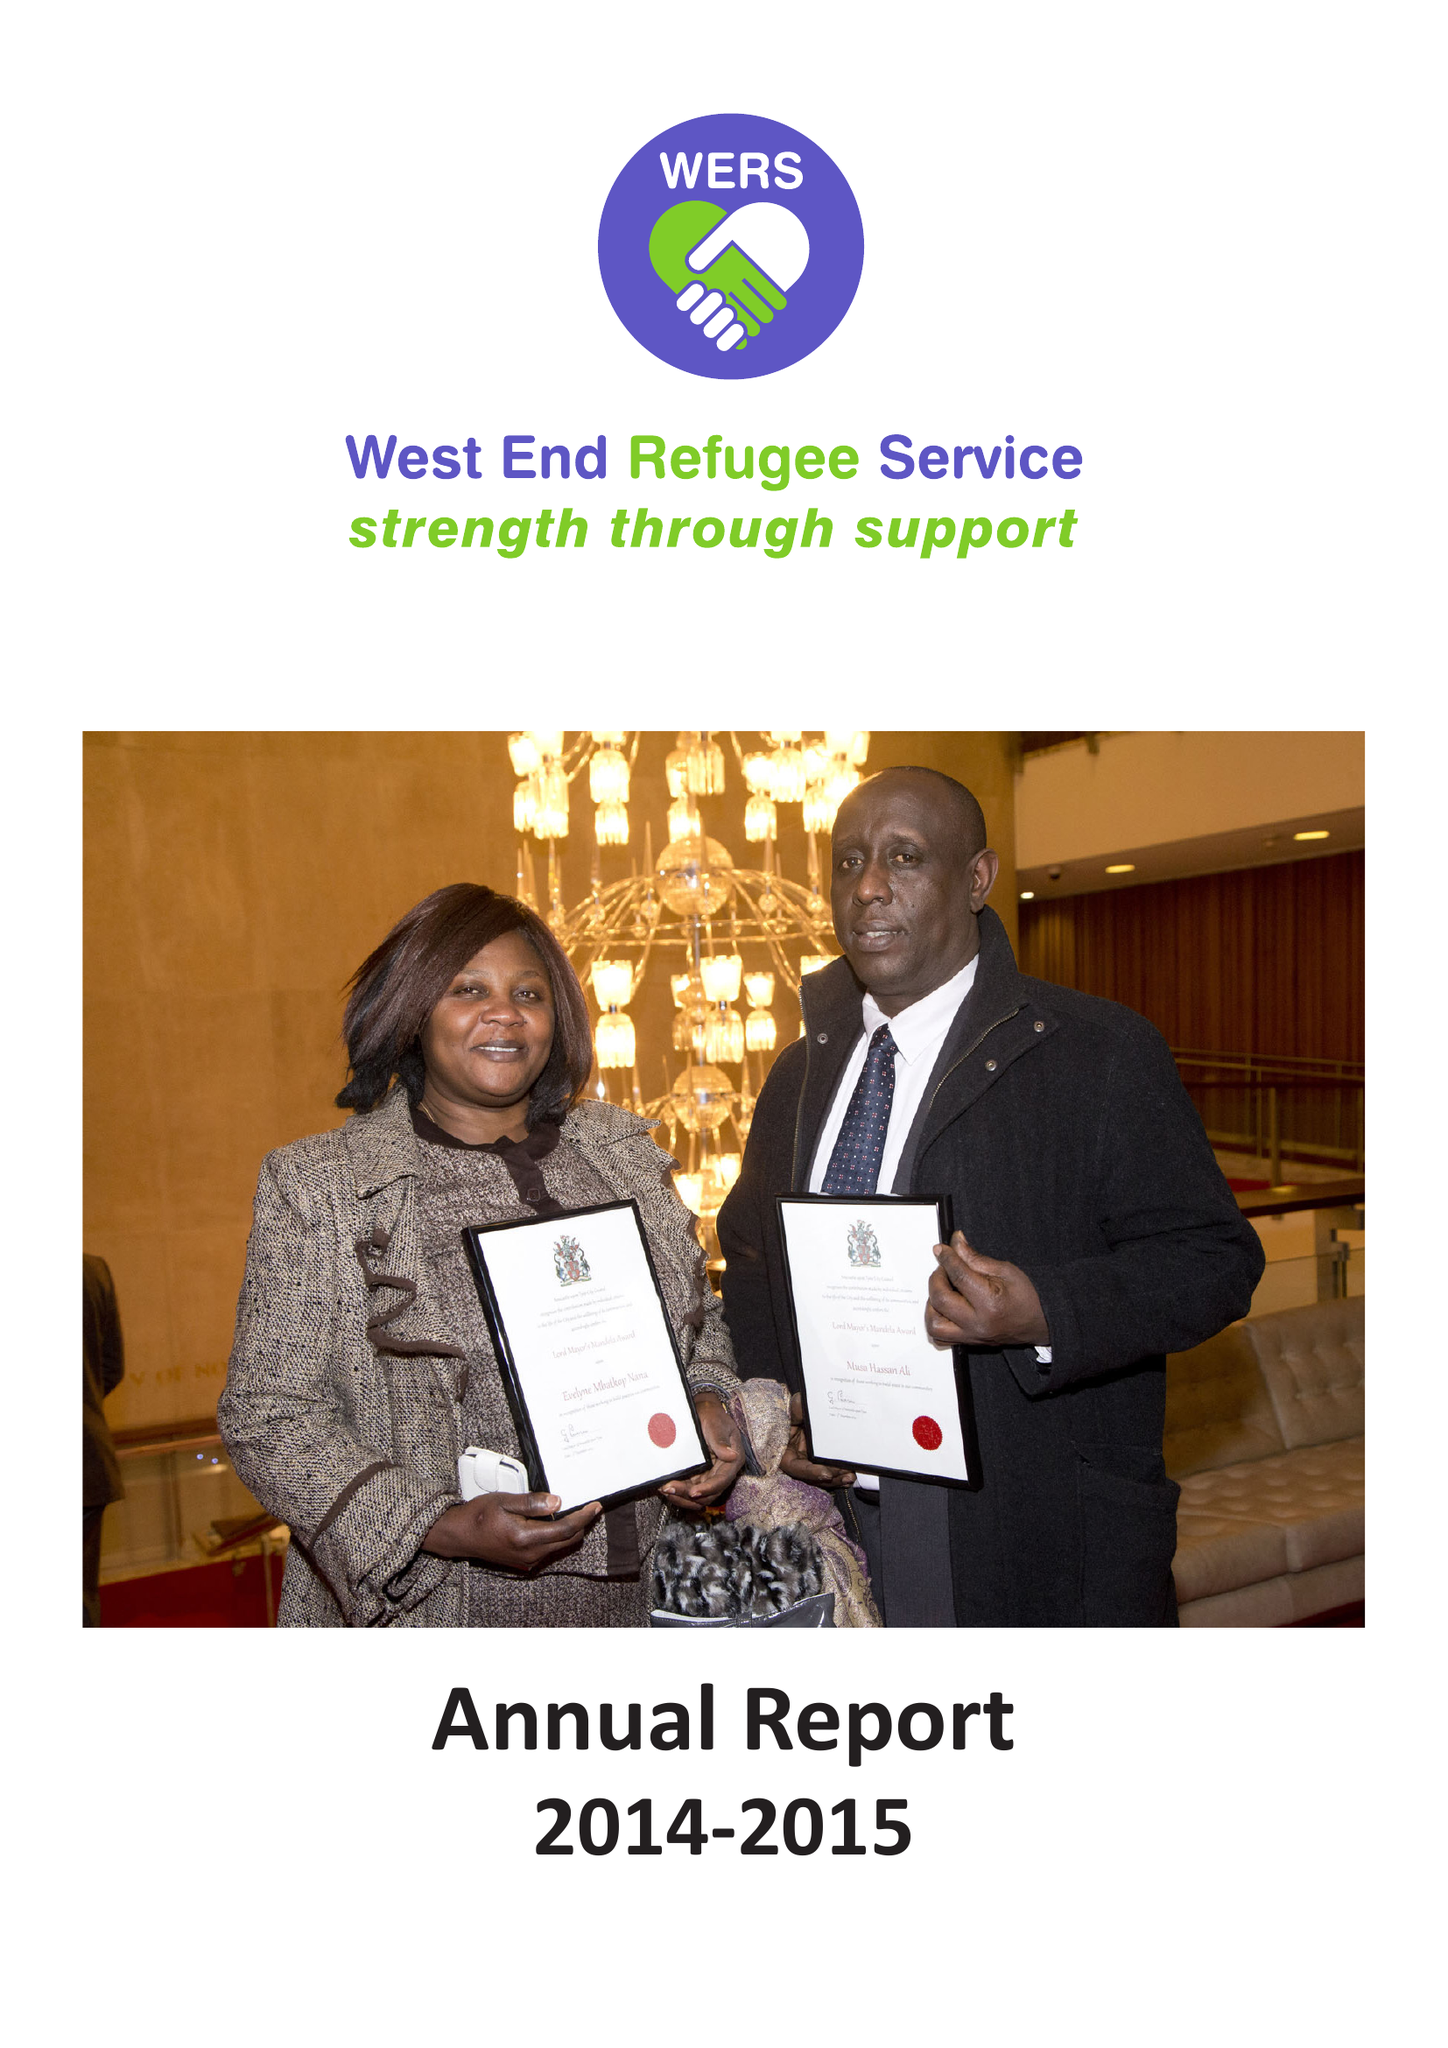What is the value for the charity_name?
Answer the question using a single word or phrase. West End Refugee Service (Wers) 